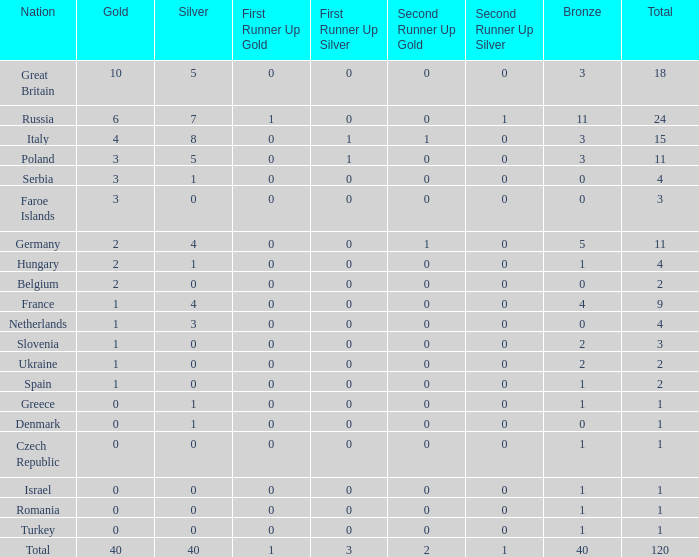What is the average Gold entry for the Netherlands that also has a Bronze entry that is greater than 0? None. 